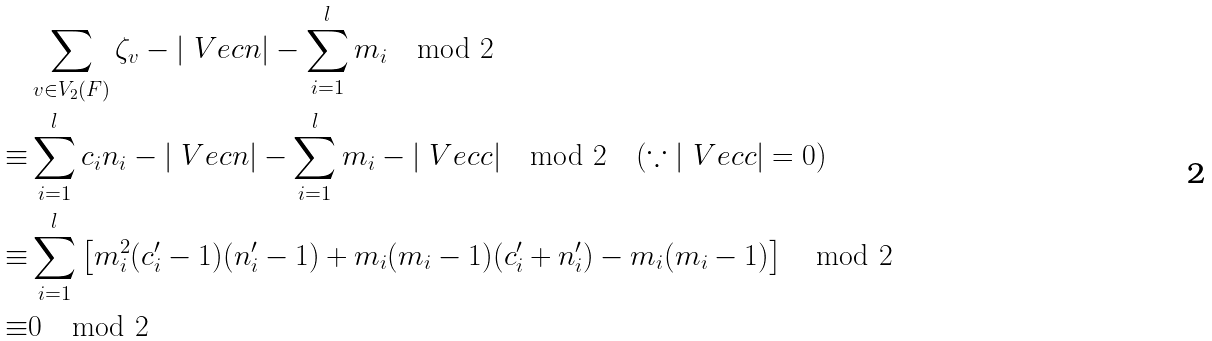Convert formula to latex. <formula><loc_0><loc_0><loc_500><loc_500>& \sum _ { v \in V _ { 2 } ( F ) } \zeta _ { v } - | \ V e c { n } | - \sum _ { i = 1 } ^ { l } m _ { i } \mod 2 \\ \equiv & \sum _ { i = 1 } ^ { l } c _ { i } n _ { i } - | \ V e c { n } | - \sum _ { i = 1 } ^ { l } m _ { i } - | \ V e c { c } | \mod 2 \quad ( \because | \ V e c { c } | = 0 ) \\ \equiv & \sum _ { i = 1 } ^ { l } \left [ m _ { i } ^ { 2 } ( c _ { i } ^ { \prime } - 1 ) ( n _ { i } ^ { \prime } - 1 ) + m _ { i } ( m _ { i } - 1 ) ( c _ { i } ^ { \prime } + n _ { i } ^ { \prime } ) - m _ { i } ( m _ { i } - 1 ) \right ] \mod 2 \\ \equiv & 0 \mod 2</formula> 